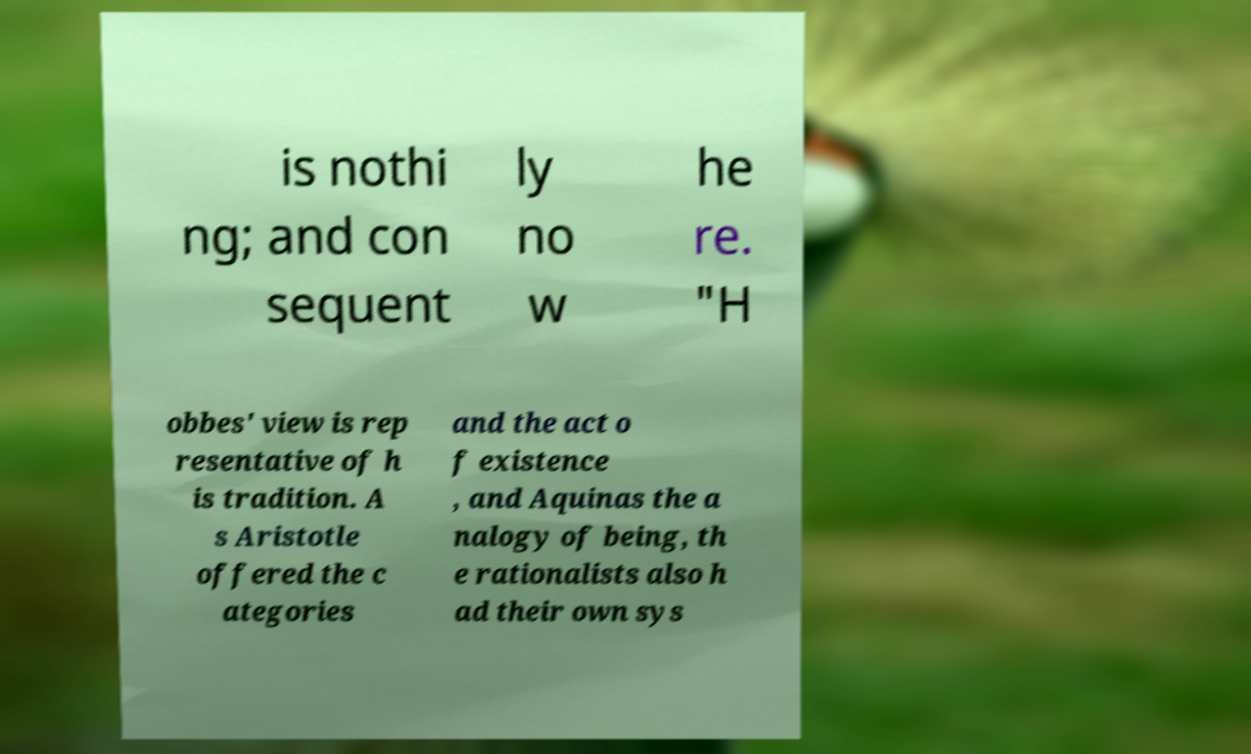Can you accurately transcribe the text from the provided image for me? is nothi ng; and con sequent ly no w he re. "H obbes' view is rep resentative of h is tradition. A s Aristotle offered the c ategories and the act o f existence , and Aquinas the a nalogy of being, th e rationalists also h ad their own sys 